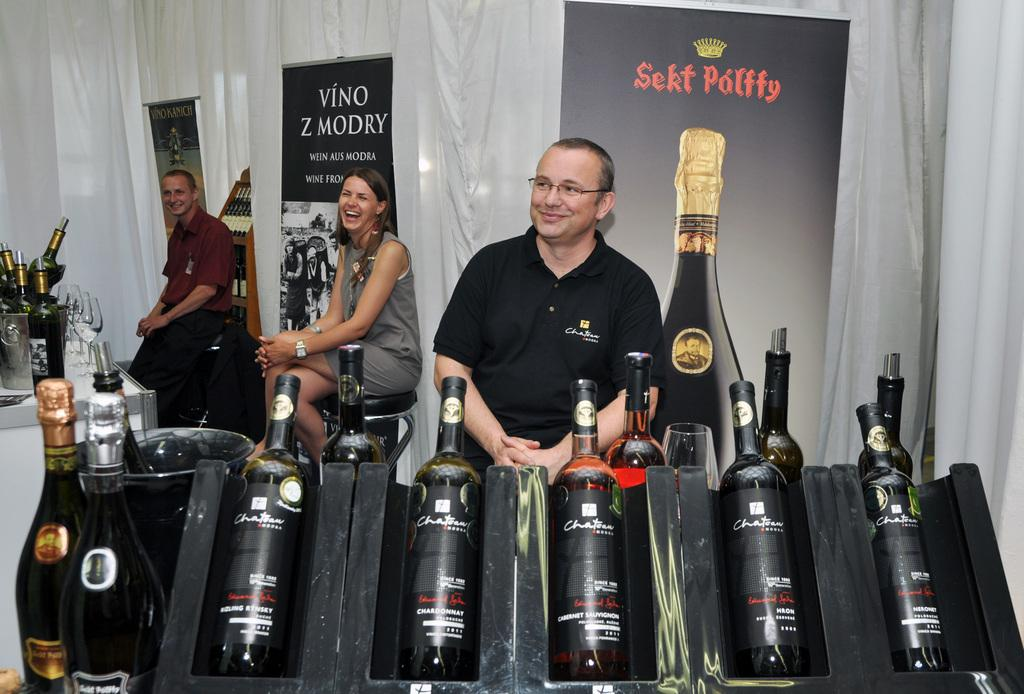What type of beverage containers are present in the image? There are wine bottles in the image. How many people are seated in the image? There are three people seated on chairs in the image. What can be seen in the background of the image? There are curtains and a hoarding in the background of the image. What type of chalk is being used by the father in the image? There is no father or chalk present in the image. 